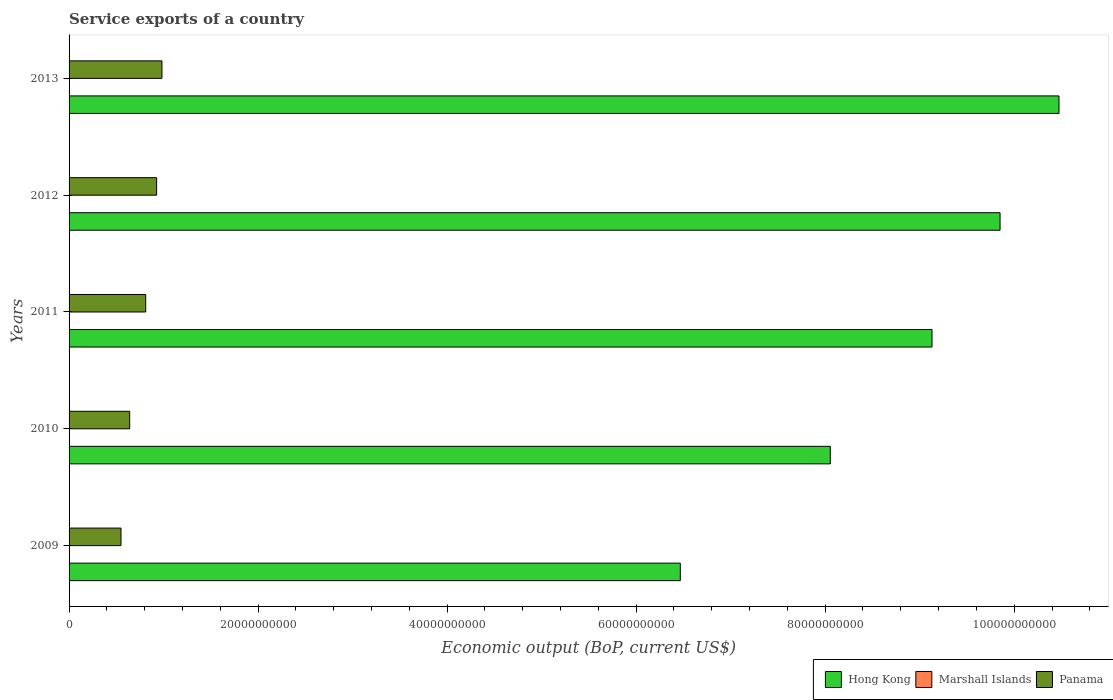Are the number of bars per tick equal to the number of legend labels?
Make the answer very short. Yes. Are the number of bars on each tick of the Y-axis equal?
Your response must be concise. Yes. How many bars are there on the 1st tick from the top?
Your response must be concise. 3. How many bars are there on the 1st tick from the bottom?
Make the answer very short. 3. What is the service exports in Marshall Islands in 2012?
Offer a terse response. 1.05e+07. Across all years, what is the maximum service exports in Marshall Islands?
Your answer should be very brief. 1.19e+07. Across all years, what is the minimum service exports in Hong Kong?
Offer a terse response. 6.47e+1. In which year was the service exports in Panama maximum?
Your response must be concise. 2013. In which year was the service exports in Panama minimum?
Offer a very short reply. 2009. What is the total service exports in Marshall Islands in the graph?
Your answer should be very brief. 5.34e+07. What is the difference between the service exports in Panama in 2009 and that in 2011?
Your answer should be compact. -2.61e+09. What is the difference between the service exports in Panama in 2013 and the service exports in Hong Kong in 2012?
Offer a terse response. -8.87e+1. What is the average service exports in Marshall Islands per year?
Your answer should be compact. 1.07e+07. In the year 2012, what is the difference between the service exports in Panama and service exports in Marshall Islands?
Your answer should be very brief. 9.25e+09. What is the ratio of the service exports in Marshall Islands in 2010 to that in 2013?
Your answer should be very brief. 0.85. Is the difference between the service exports in Panama in 2009 and 2013 greater than the difference between the service exports in Marshall Islands in 2009 and 2013?
Provide a short and direct response. No. What is the difference between the highest and the second highest service exports in Marshall Islands?
Keep it short and to the point. 1.05e+06. What is the difference between the highest and the lowest service exports in Hong Kong?
Your answer should be compact. 4.01e+1. What does the 3rd bar from the top in 2012 represents?
Your answer should be compact. Hong Kong. What does the 3rd bar from the bottom in 2013 represents?
Your response must be concise. Panama. How many bars are there?
Your response must be concise. 15. Are all the bars in the graph horizontal?
Offer a very short reply. Yes. Are the values on the major ticks of X-axis written in scientific E-notation?
Keep it short and to the point. No. Does the graph contain any zero values?
Provide a succinct answer. No. How many legend labels are there?
Provide a short and direct response. 3. How are the legend labels stacked?
Make the answer very short. Horizontal. What is the title of the graph?
Provide a succinct answer. Service exports of a country. What is the label or title of the X-axis?
Keep it short and to the point. Economic output (BoP, current US$). What is the Economic output (BoP, current US$) of Hong Kong in 2009?
Your response must be concise. 6.47e+1. What is the Economic output (BoP, current US$) of Marshall Islands in 2009?
Your answer should be very brief. 1.01e+07. What is the Economic output (BoP, current US$) in Panama in 2009?
Your answer should be compact. 5.49e+09. What is the Economic output (BoP, current US$) in Hong Kong in 2010?
Provide a short and direct response. 8.05e+1. What is the Economic output (BoP, current US$) in Marshall Islands in 2010?
Ensure brevity in your answer.  1.01e+07. What is the Economic output (BoP, current US$) in Panama in 2010?
Your answer should be very brief. 6.41e+09. What is the Economic output (BoP, current US$) of Hong Kong in 2011?
Give a very brief answer. 9.13e+1. What is the Economic output (BoP, current US$) in Marshall Islands in 2011?
Your answer should be compact. 1.08e+07. What is the Economic output (BoP, current US$) of Panama in 2011?
Provide a succinct answer. 8.11e+09. What is the Economic output (BoP, current US$) of Hong Kong in 2012?
Provide a succinct answer. 9.85e+1. What is the Economic output (BoP, current US$) in Marshall Islands in 2012?
Your response must be concise. 1.05e+07. What is the Economic output (BoP, current US$) in Panama in 2012?
Ensure brevity in your answer.  9.26e+09. What is the Economic output (BoP, current US$) of Hong Kong in 2013?
Offer a very short reply. 1.05e+11. What is the Economic output (BoP, current US$) of Marshall Islands in 2013?
Your answer should be very brief. 1.19e+07. What is the Economic output (BoP, current US$) in Panama in 2013?
Your answer should be very brief. 9.83e+09. Across all years, what is the maximum Economic output (BoP, current US$) in Hong Kong?
Your answer should be very brief. 1.05e+11. Across all years, what is the maximum Economic output (BoP, current US$) in Marshall Islands?
Your answer should be compact. 1.19e+07. Across all years, what is the maximum Economic output (BoP, current US$) of Panama?
Provide a succinct answer. 9.83e+09. Across all years, what is the minimum Economic output (BoP, current US$) of Hong Kong?
Your response must be concise. 6.47e+1. Across all years, what is the minimum Economic output (BoP, current US$) in Marshall Islands?
Keep it short and to the point. 1.01e+07. Across all years, what is the minimum Economic output (BoP, current US$) of Panama?
Keep it short and to the point. 5.49e+09. What is the total Economic output (BoP, current US$) in Hong Kong in the graph?
Keep it short and to the point. 4.40e+11. What is the total Economic output (BoP, current US$) in Marshall Islands in the graph?
Provide a succinct answer. 5.34e+07. What is the total Economic output (BoP, current US$) of Panama in the graph?
Offer a terse response. 3.91e+1. What is the difference between the Economic output (BoP, current US$) of Hong Kong in 2009 and that in 2010?
Offer a terse response. -1.59e+1. What is the difference between the Economic output (BoP, current US$) in Marshall Islands in 2009 and that in 2010?
Give a very brief answer. 3.96e+04. What is the difference between the Economic output (BoP, current US$) of Panama in 2009 and that in 2010?
Provide a short and direct response. -9.17e+08. What is the difference between the Economic output (BoP, current US$) of Hong Kong in 2009 and that in 2011?
Give a very brief answer. -2.66e+1. What is the difference between the Economic output (BoP, current US$) of Marshall Islands in 2009 and that in 2011?
Offer a terse response. -6.61e+05. What is the difference between the Economic output (BoP, current US$) in Panama in 2009 and that in 2011?
Provide a short and direct response. -2.61e+09. What is the difference between the Economic output (BoP, current US$) of Hong Kong in 2009 and that in 2012?
Offer a very short reply. -3.38e+1. What is the difference between the Economic output (BoP, current US$) of Marshall Islands in 2009 and that in 2012?
Keep it short and to the point. -3.64e+05. What is the difference between the Economic output (BoP, current US$) of Panama in 2009 and that in 2012?
Give a very brief answer. -3.77e+09. What is the difference between the Economic output (BoP, current US$) of Hong Kong in 2009 and that in 2013?
Keep it short and to the point. -4.01e+1. What is the difference between the Economic output (BoP, current US$) in Marshall Islands in 2009 and that in 2013?
Provide a succinct answer. -1.71e+06. What is the difference between the Economic output (BoP, current US$) in Panama in 2009 and that in 2013?
Your response must be concise. -4.33e+09. What is the difference between the Economic output (BoP, current US$) in Hong Kong in 2010 and that in 2011?
Your answer should be very brief. -1.08e+1. What is the difference between the Economic output (BoP, current US$) in Marshall Islands in 2010 and that in 2011?
Provide a short and direct response. -7.01e+05. What is the difference between the Economic output (BoP, current US$) of Panama in 2010 and that in 2011?
Keep it short and to the point. -1.70e+09. What is the difference between the Economic output (BoP, current US$) in Hong Kong in 2010 and that in 2012?
Keep it short and to the point. -1.80e+1. What is the difference between the Economic output (BoP, current US$) in Marshall Islands in 2010 and that in 2012?
Your answer should be compact. -4.03e+05. What is the difference between the Economic output (BoP, current US$) of Panama in 2010 and that in 2012?
Provide a succinct answer. -2.85e+09. What is the difference between the Economic output (BoP, current US$) in Hong Kong in 2010 and that in 2013?
Provide a succinct answer. -2.42e+1. What is the difference between the Economic output (BoP, current US$) of Marshall Islands in 2010 and that in 2013?
Ensure brevity in your answer.  -1.75e+06. What is the difference between the Economic output (BoP, current US$) in Panama in 2010 and that in 2013?
Ensure brevity in your answer.  -3.42e+09. What is the difference between the Economic output (BoP, current US$) of Hong Kong in 2011 and that in 2012?
Your response must be concise. -7.20e+09. What is the difference between the Economic output (BoP, current US$) in Marshall Islands in 2011 and that in 2012?
Your answer should be compact. 2.97e+05. What is the difference between the Economic output (BoP, current US$) in Panama in 2011 and that in 2012?
Your answer should be very brief. -1.16e+09. What is the difference between the Economic output (BoP, current US$) in Hong Kong in 2011 and that in 2013?
Offer a very short reply. -1.34e+1. What is the difference between the Economic output (BoP, current US$) in Marshall Islands in 2011 and that in 2013?
Offer a terse response. -1.05e+06. What is the difference between the Economic output (BoP, current US$) of Panama in 2011 and that in 2013?
Your answer should be compact. -1.72e+09. What is the difference between the Economic output (BoP, current US$) of Hong Kong in 2012 and that in 2013?
Your answer should be very brief. -6.23e+09. What is the difference between the Economic output (BoP, current US$) in Marshall Islands in 2012 and that in 2013?
Make the answer very short. -1.35e+06. What is the difference between the Economic output (BoP, current US$) of Panama in 2012 and that in 2013?
Your answer should be compact. -5.64e+08. What is the difference between the Economic output (BoP, current US$) of Hong Kong in 2009 and the Economic output (BoP, current US$) of Marshall Islands in 2010?
Keep it short and to the point. 6.47e+1. What is the difference between the Economic output (BoP, current US$) of Hong Kong in 2009 and the Economic output (BoP, current US$) of Panama in 2010?
Ensure brevity in your answer.  5.83e+1. What is the difference between the Economic output (BoP, current US$) in Marshall Islands in 2009 and the Economic output (BoP, current US$) in Panama in 2010?
Keep it short and to the point. -6.40e+09. What is the difference between the Economic output (BoP, current US$) of Hong Kong in 2009 and the Economic output (BoP, current US$) of Marshall Islands in 2011?
Offer a very short reply. 6.47e+1. What is the difference between the Economic output (BoP, current US$) in Hong Kong in 2009 and the Economic output (BoP, current US$) in Panama in 2011?
Your answer should be compact. 5.66e+1. What is the difference between the Economic output (BoP, current US$) in Marshall Islands in 2009 and the Economic output (BoP, current US$) in Panama in 2011?
Your answer should be compact. -8.10e+09. What is the difference between the Economic output (BoP, current US$) of Hong Kong in 2009 and the Economic output (BoP, current US$) of Marshall Islands in 2012?
Your response must be concise. 6.47e+1. What is the difference between the Economic output (BoP, current US$) in Hong Kong in 2009 and the Economic output (BoP, current US$) in Panama in 2012?
Make the answer very short. 5.54e+1. What is the difference between the Economic output (BoP, current US$) of Marshall Islands in 2009 and the Economic output (BoP, current US$) of Panama in 2012?
Offer a very short reply. -9.25e+09. What is the difference between the Economic output (BoP, current US$) in Hong Kong in 2009 and the Economic output (BoP, current US$) in Marshall Islands in 2013?
Your answer should be compact. 6.47e+1. What is the difference between the Economic output (BoP, current US$) of Hong Kong in 2009 and the Economic output (BoP, current US$) of Panama in 2013?
Give a very brief answer. 5.48e+1. What is the difference between the Economic output (BoP, current US$) of Marshall Islands in 2009 and the Economic output (BoP, current US$) of Panama in 2013?
Your answer should be compact. -9.82e+09. What is the difference between the Economic output (BoP, current US$) in Hong Kong in 2010 and the Economic output (BoP, current US$) in Marshall Islands in 2011?
Your response must be concise. 8.05e+1. What is the difference between the Economic output (BoP, current US$) in Hong Kong in 2010 and the Economic output (BoP, current US$) in Panama in 2011?
Make the answer very short. 7.24e+1. What is the difference between the Economic output (BoP, current US$) in Marshall Islands in 2010 and the Economic output (BoP, current US$) in Panama in 2011?
Give a very brief answer. -8.10e+09. What is the difference between the Economic output (BoP, current US$) of Hong Kong in 2010 and the Economic output (BoP, current US$) of Marshall Islands in 2012?
Your answer should be very brief. 8.05e+1. What is the difference between the Economic output (BoP, current US$) of Hong Kong in 2010 and the Economic output (BoP, current US$) of Panama in 2012?
Provide a succinct answer. 7.13e+1. What is the difference between the Economic output (BoP, current US$) in Marshall Islands in 2010 and the Economic output (BoP, current US$) in Panama in 2012?
Make the answer very short. -9.25e+09. What is the difference between the Economic output (BoP, current US$) of Hong Kong in 2010 and the Economic output (BoP, current US$) of Marshall Islands in 2013?
Provide a short and direct response. 8.05e+1. What is the difference between the Economic output (BoP, current US$) of Hong Kong in 2010 and the Economic output (BoP, current US$) of Panama in 2013?
Make the answer very short. 7.07e+1. What is the difference between the Economic output (BoP, current US$) in Marshall Islands in 2010 and the Economic output (BoP, current US$) in Panama in 2013?
Your response must be concise. -9.82e+09. What is the difference between the Economic output (BoP, current US$) in Hong Kong in 2011 and the Economic output (BoP, current US$) in Marshall Islands in 2012?
Ensure brevity in your answer.  9.13e+1. What is the difference between the Economic output (BoP, current US$) in Hong Kong in 2011 and the Economic output (BoP, current US$) in Panama in 2012?
Offer a very short reply. 8.20e+1. What is the difference between the Economic output (BoP, current US$) of Marshall Islands in 2011 and the Economic output (BoP, current US$) of Panama in 2012?
Make the answer very short. -9.25e+09. What is the difference between the Economic output (BoP, current US$) in Hong Kong in 2011 and the Economic output (BoP, current US$) in Marshall Islands in 2013?
Give a very brief answer. 9.13e+1. What is the difference between the Economic output (BoP, current US$) of Hong Kong in 2011 and the Economic output (BoP, current US$) of Panama in 2013?
Offer a terse response. 8.15e+1. What is the difference between the Economic output (BoP, current US$) of Marshall Islands in 2011 and the Economic output (BoP, current US$) of Panama in 2013?
Keep it short and to the point. -9.82e+09. What is the difference between the Economic output (BoP, current US$) of Hong Kong in 2012 and the Economic output (BoP, current US$) of Marshall Islands in 2013?
Your response must be concise. 9.85e+1. What is the difference between the Economic output (BoP, current US$) of Hong Kong in 2012 and the Economic output (BoP, current US$) of Panama in 2013?
Offer a very short reply. 8.87e+1. What is the difference between the Economic output (BoP, current US$) of Marshall Islands in 2012 and the Economic output (BoP, current US$) of Panama in 2013?
Your answer should be very brief. -9.82e+09. What is the average Economic output (BoP, current US$) in Hong Kong per year?
Your answer should be compact. 8.80e+1. What is the average Economic output (BoP, current US$) of Marshall Islands per year?
Give a very brief answer. 1.07e+07. What is the average Economic output (BoP, current US$) of Panama per year?
Keep it short and to the point. 7.82e+09. In the year 2009, what is the difference between the Economic output (BoP, current US$) in Hong Kong and Economic output (BoP, current US$) in Marshall Islands?
Keep it short and to the point. 6.47e+1. In the year 2009, what is the difference between the Economic output (BoP, current US$) in Hong Kong and Economic output (BoP, current US$) in Panama?
Provide a succinct answer. 5.92e+1. In the year 2009, what is the difference between the Economic output (BoP, current US$) in Marshall Islands and Economic output (BoP, current US$) in Panama?
Make the answer very short. -5.48e+09. In the year 2010, what is the difference between the Economic output (BoP, current US$) in Hong Kong and Economic output (BoP, current US$) in Marshall Islands?
Offer a very short reply. 8.05e+1. In the year 2010, what is the difference between the Economic output (BoP, current US$) of Hong Kong and Economic output (BoP, current US$) of Panama?
Your answer should be compact. 7.41e+1. In the year 2010, what is the difference between the Economic output (BoP, current US$) in Marshall Islands and Economic output (BoP, current US$) in Panama?
Offer a very short reply. -6.40e+09. In the year 2011, what is the difference between the Economic output (BoP, current US$) of Hong Kong and Economic output (BoP, current US$) of Marshall Islands?
Your answer should be compact. 9.13e+1. In the year 2011, what is the difference between the Economic output (BoP, current US$) in Hong Kong and Economic output (BoP, current US$) in Panama?
Give a very brief answer. 8.32e+1. In the year 2011, what is the difference between the Economic output (BoP, current US$) in Marshall Islands and Economic output (BoP, current US$) in Panama?
Provide a short and direct response. -8.10e+09. In the year 2012, what is the difference between the Economic output (BoP, current US$) of Hong Kong and Economic output (BoP, current US$) of Marshall Islands?
Provide a succinct answer. 9.85e+1. In the year 2012, what is the difference between the Economic output (BoP, current US$) in Hong Kong and Economic output (BoP, current US$) in Panama?
Provide a short and direct response. 8.92e+1. In the year 2012, what is the difference between the Economic output (BoP, current US$) of Marshall Islands and Economic output (BoP, current US$) of Panama?
Ensure brevity in your answer.  -9.25e+09. In the year 2013, what is the difference between the Economic output (BoP, current US$) in Hong Kong and Economic output (BoP, current US$) in Marshall Islands?
Provide a succinct answer. 1.05e+11. In the year 2013, what is the difference between the Economic output (BoP, current US$) in Hong Kong and Economic output (BoP, current US$) in Panama?
Offer a terse response. 9.49e+1. In the year 2013, what is the difference between the Economic output (BoP, current US$) of Marshall Islands and Economic output (BoP, current US$) of Panama?
Provide a succinct answer. -9.82e+09. What is the ratio of the Economic output (BoP, current US$) of Hong Kong in 2009 to that in 2010?
Provide a short and direct response. 0.8. What is the ratio of the Economic output (BoP, current US$) of Panama in 2009 to that in 2010?
Give a very brief answer. 0.86. What is the ratio of the Economic output (BoP, current US$) in Hong Kong in 2009 to that in 2011?
Provide a short and direct response. 0.71. What is the ratio of the Economic output (BoP, current US$) in Marshall Islands in 2009 to that in 2011?
Your answer should be compact. 0.94. What is the ratio of the Economic output (BoP, current US$) in Panama in 2009 to that in 2011?
Give a very brief answer. 0.68. What is the ratio of the Economic output (BoP, current US$) of Hong Kong in 2009 to that in 2012?
Ensure brevity in your answer.  0.66. What is the ratio of the Economic output (BoP, current US$) in Marshall Islands in 2009 to that in 2012?
Provide a short and direct response. 0.97. What is the ratio of the Economic output (BoP, current US$) in Panama in 2009 to that in 2012?
Make the answer very short. 0.59. What is the ratio of the Economic output (BoP, current US$) of Hong Kong in 2009 to that in 2013?
Make the answer very short. 0.62. What is the ratio of the Economic output (BoP, current US$) of Marshall Islands in 2009 to that in 2013?
Make the answer very short. 0.86. What is the ratio of the Economic output (BoP, current US$) in Panama in 2009 to that in 2013?
Make the answer very short. 0.56. What is the ratio of the Economic output (BoP, current US$) of Hong Kong in 2010 to that in 2011?
Your answer should be very brief. 0.88. What is the ratio of the Economic output (BoP, current US$) in Marshall Islands in 2010 to that in 2011?
Give a very brief answer. 0.94. What is the ratio of the Economic output (BoP, current US$) of Panama in 2010 to that in 2011?
Keep it short and to the point. 0.79. What is the ratio of the Economic output (BoP, current US$) in Hong Kong in 2010 to that in 2012?
Offer a very short reply. 0.82. What is the ratio of the Economic output (BoP, current US$) in Marshall Islands in 2010 to that in 2012?
Provide a short and direct response. 0.96. What is the ratio of the Economic output (BoP, current US$) in Panama in 2010 to that in 2012?
Ensure brevity in your answer.  0.69. What is the ratio of the Economic output (BoP, current US$) of Hong Kong in 2010 to that in 2013?
Keep it short and to the point. 0.77. What is the ratio of the Economic output (BoP, current US$) in Marshall Islands in 2010 to that in 2013?
Provide a short and direct response. 0.85. What is the ratio of the Economic output (BoP, current US$) in Panama in 2010 to that in 2013?
Make the answer very short. 0.65. What is the ratio of the Economic output (BoP, current US$) of Hong Kong in 2011 to that in 2012?
Your response must be concise. 0.93. What is the ratio of the Economic output (BoP, current US$) in Marshall Islands in 2011 to that in 2012?
Offer a terse response. 1.03. What is the ratio of the Economic output (BoP, current US$) of Panama in 2011 to that in 2012?
Your response must be concise. 0.88. What is the ratio of the Economic output (BoP, current US$) in Hong Kong in 2011 to that in 2013?
Your response must be concise. 0.87. What is the ratio of the Economic output (BoP, current US$) in Marshall Islands in 2011 to that in 2013?
Offer a terse response. 0.91. What is the ratio of the Economic output (BoP, current US$) of Panama in 2011 to that in 2013?
Make the answer very short. 0.83. What is the ratio of the Economic output (BoP, current US$) in Hong Kong in 2012 to that in 2013?
Make the answer very short. 0.94. What is the ratio of the Economic output (BoP, current US$) of Marshall Islands in 2012 to that in 2013?
Offer a terse response. 0.89. What is the ratio of the Economic output (BoP, current US$) of Panama in 2012 to that in 2013?
Provide a short and direct response. 0.94. What is the difference between the highest and the second highest Economic output (BoP, current US$) of Hong Kong?
Give a very brief answer. 6.23e+09. What is the difference between the highest and the second highest Economic output (BoP, current US$) in Marshall Islands?
Provide a short and direct response. 1.05e+06. What is the difference between the highest and the second highest Economic output (BoP, current US$) of Panama?
Your response must be concise. 5.64e+08. What is the difference between the highest and the lowest Economic output (BoP, current US$) of Hong Kong?
Offer a very short reply. 4.01e+1. What is the difference between the highest and the lowest Economic output (BoP, current US$) in Marshall Islands?
Offer a terse response. 1.75e+06. What is the difference between the highest and the lowest Economic output (BoP, current US$) in Panama?
Offer a terse response. 4.33e+09. 